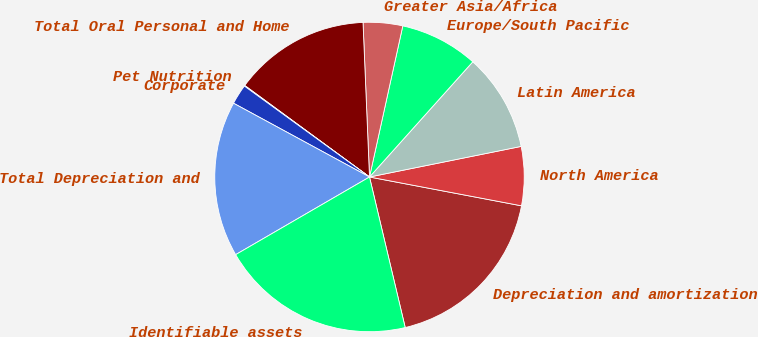<chart> <loc_0><loc_0><loc_500><loc_500><pie_chart><fcel>Depreciation and amortization<fcel>North America<fcel>Latin America<fcel>Europe/South Pacific<fcel>Greater Asia/Africa<fcel>Total Oral Personal and Home<fcel>Pet Nutrition<fcel>Corporate<fcel>Total Depreciation and<fcel>Identifiable assets<nl><fcel>18.31%<fcel>6.15%<fcel>10.2%<fcel>8.18%<fcel>4.12%<fcel>14.26%<fcel>0.07%<fcel>2.09%<fcel>16.28%<fcel>20.34%<nl></chart> 